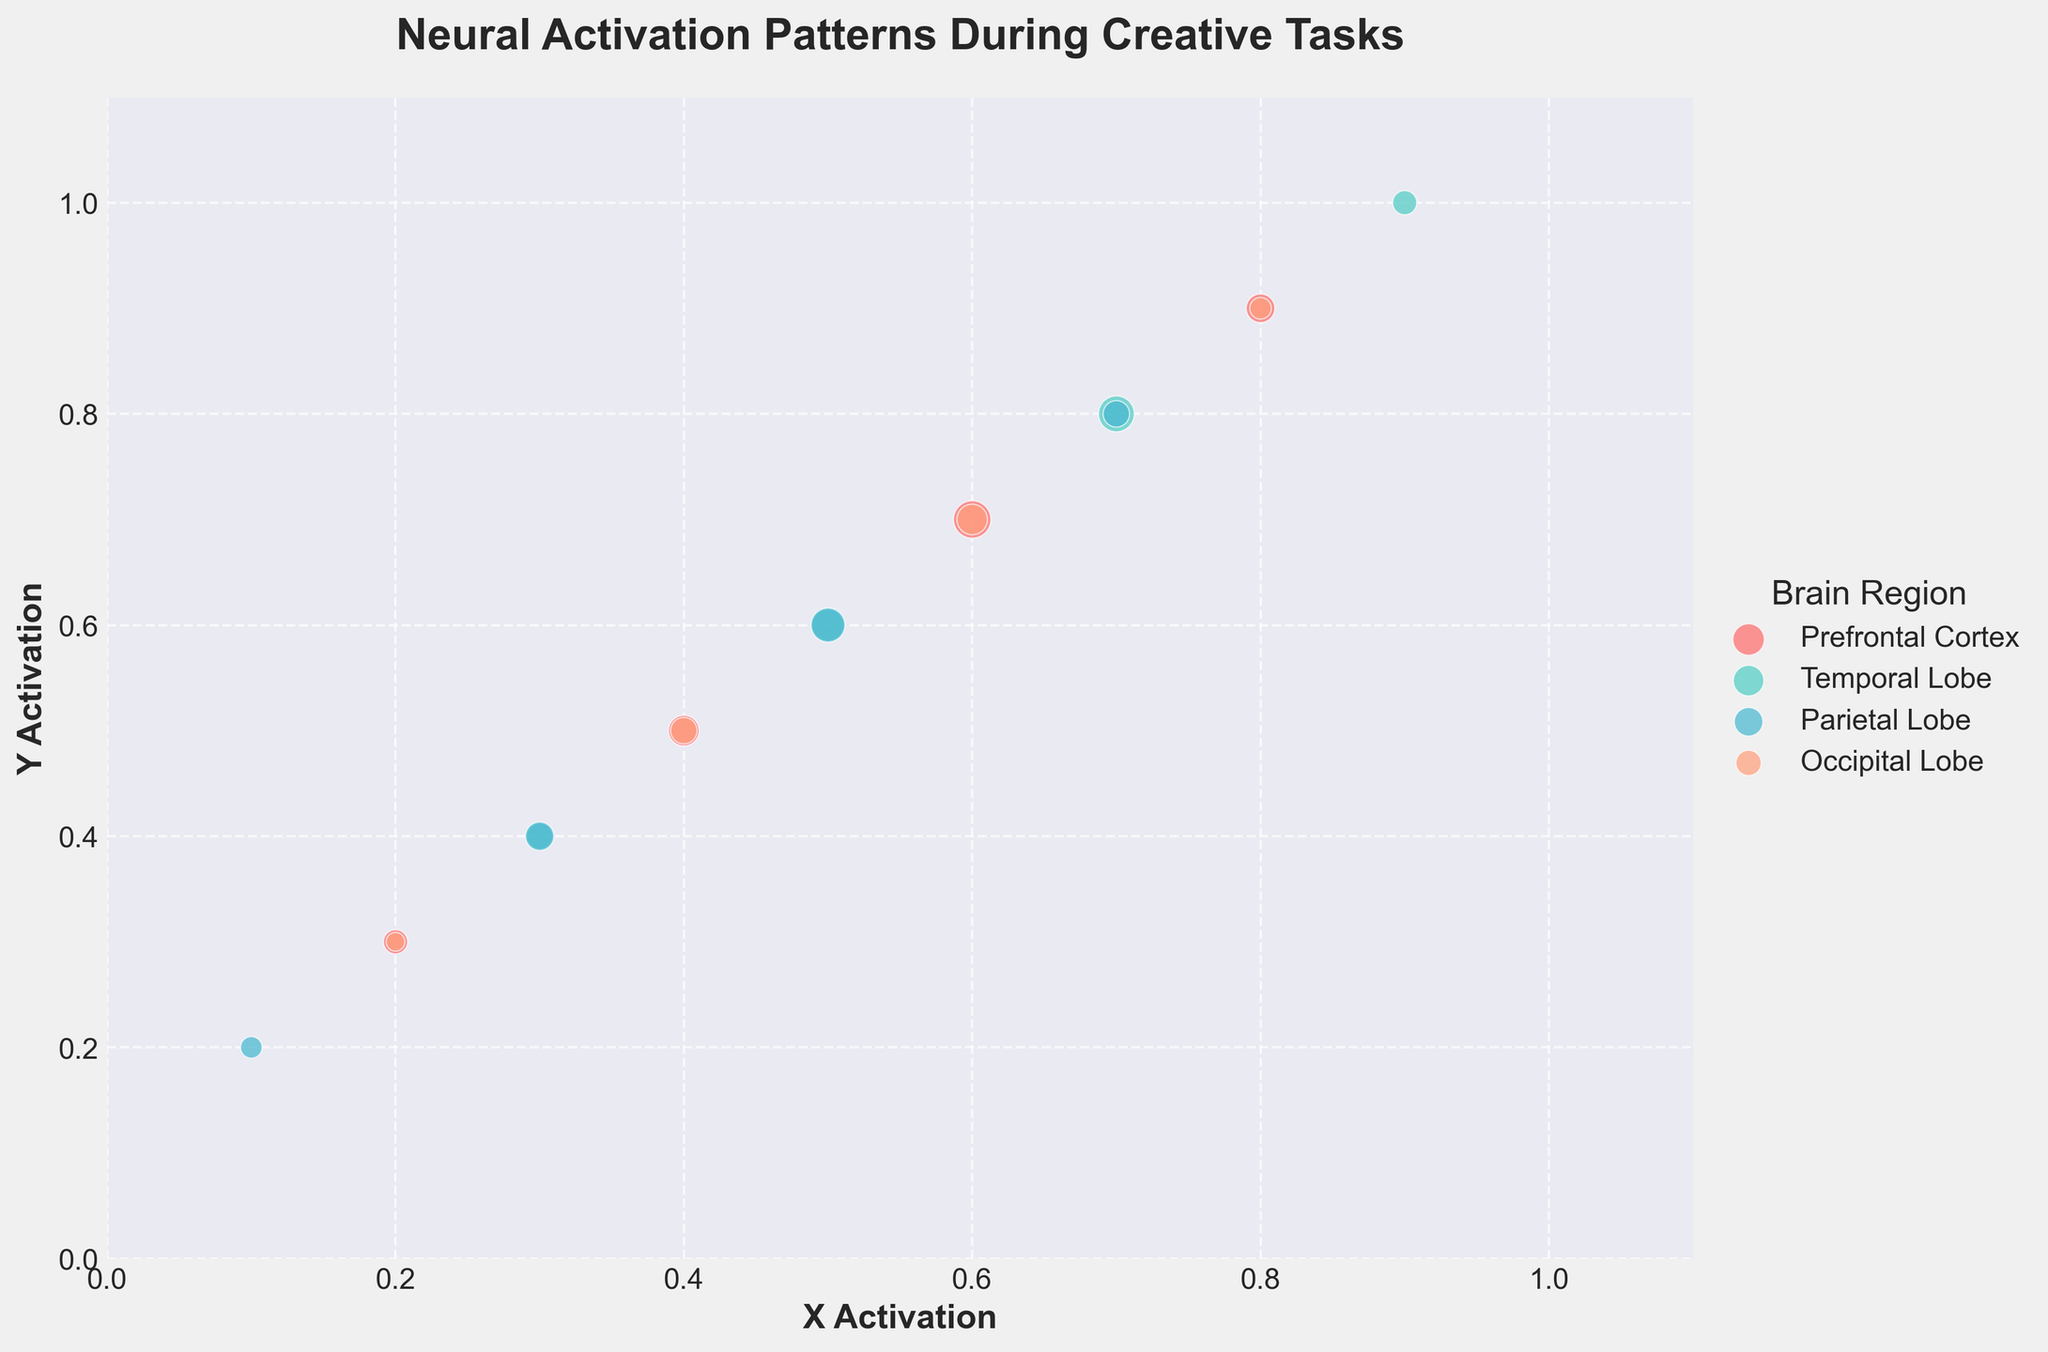What is the title of the plot? The title of the plot is displayed at the top center and reads 'Neural Activation Patterns During Creative Tasks' in large, bold font.
Answer: Neural Activation Patterns During Creative Tasks What are the colors used to represent different brain regions? The scatterplot uses distinct colors to represent different brain regions: red for Prefrontal Cortex, green for Temporal Lobe, blue for Parietal Lobe, and orange for Occipital Lobe.
Answer: Red, Green, Blue, Orange How many data points are there for the Prefrontal Cortex? By identifying the red (Prefrontal Cortex) dots on the plot and counting them, we can see there are four data points.
Answer: 4 Which brain region has the highest frequency value and what is that value? By examining the size of the scatter points (indicating frequency), we find that the largest point is for the Prefrontal Cortex with a frequency labeled as 12.
Answer: Prefrontal Cortex, 12 Across all brain regions, what is the range of x_activation values? Observing the scatterplot, the x_activation values span from the smallest value at 0.1 in the Parietal Lobe to the largest value at 0.9 in both the Prefrontal Cortex and Temporal Lobe.
Answer: 0.1 to 0.9 Which brain region shows the most distributed neural activation patterns across the X and Y axes? By comparing the scatter points' spread on both axes, the Temporal Lobe (green dots) showcases activation patterns ranging considerably from low to high values in both directions.
Answer: Temporal Lobe How does the average frequency compare between the Parietal Lobe and Occipital Lobe? Adding the frequency values for the Parietal Lobe (4, 7, 10, 6) and for the Occipital Lobe (3, 6, 8, 4), then averaging: Parietal Lobe: (4+7+10+6)/4 = 6.75; Occipital Lobe: (3+6+8+4)/4 = 5.25. The Parietal Lobe has a higher average frequency.
Answer: Parietal Lobe has a higher average What is the overall density pattern in terms of neural activation frequencies? Observing the scatterplot, it appears that mid-range x and y activation values (0.5 to 0.7) have the highest density, indicating that neural activation frequencies center around these values for most brain regions.
Answer: Mid-range values, 0.5 to 0.7 Do any two brain regions share the same activation frequency for any point? By cross-referencing the scatter points, only the Prefrontal Cortex and the Parietal Lobe share similar activation points but none share the exact same frequency values for any activation coordinates (x, y).
Answer: No Which brain region has the most clustered data points in a specific activation range? Noticing clusters in the scatterplot, the Temporal Lobe (green dots) shows a noticeable concentration of points around x and y values from 0.5 to 0.8.
Answer: Temporal Lobe 